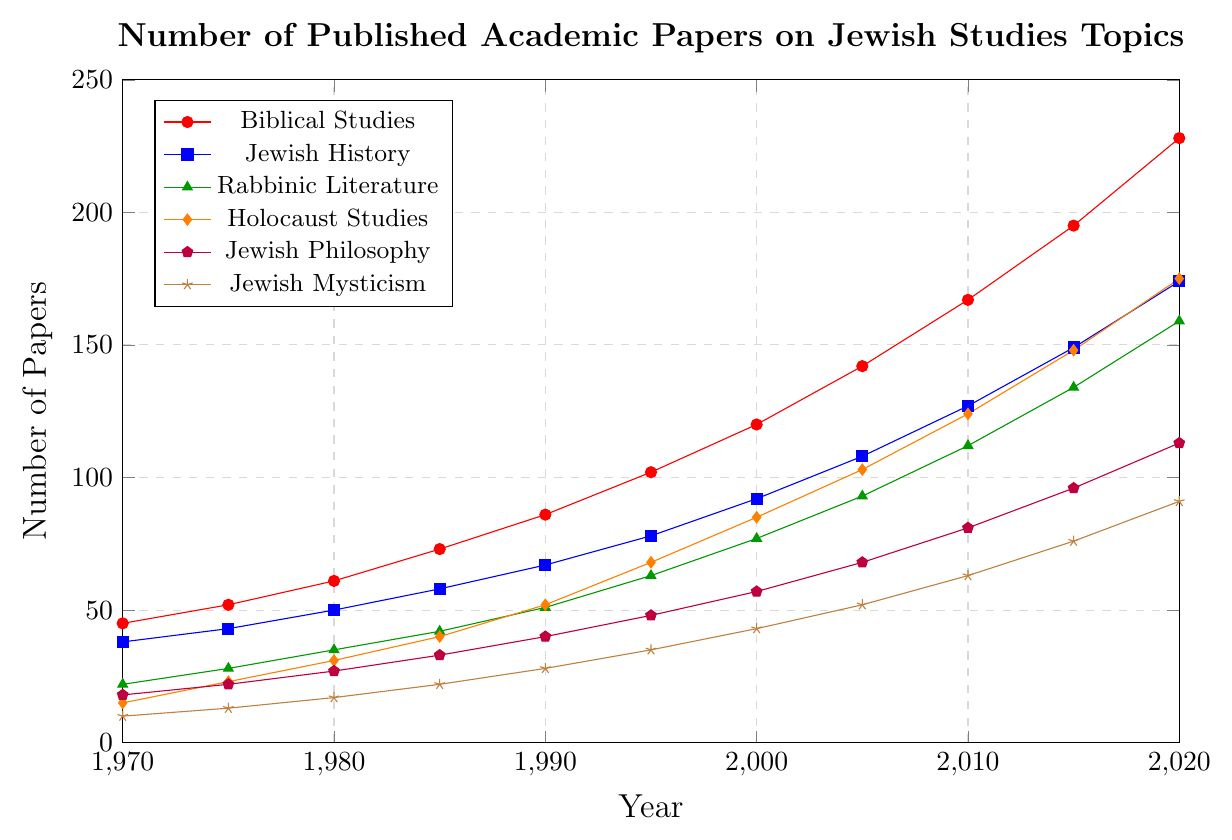What specific year does Holocaust Studies surpass 100 published papers? Examining the trend line for Holocaust Studies (orange line with diamond markers), we can see that it crosses 100 papers between 2000 and 2005. Checking the legend, we find that in 2005 the number is 103.
Answer: 2005 Between 1970 and 2020, which subject showed the largest increase in the number of published papers? To find the largest increase, we need to calculate the difference between the values at 2020 and 1970 for each subject. For Biblical Studies: 228-45=183, Jewish History: 174-38=136, Rabbinic Literature: 159-22=137, Holocaust Studies: 175-15=160, Jewish Philosophy: 113-18=95, and Jewish Mysticism: 91-10=81. The subject with the largest increase is Biblical Studies (183 papers).
Answer: Biblical Studies Which subject had the slowest growth over these 50 years, and what was the total growth in that subject? By calculating the increase for each subject, the smallest increase is in Jewish Mysticism: from 10 papers in 1970 to 91 in 2020, which is a difference of 81.
Answer: Jewish Mysticism, 81 In what year did the number of papers on Rabbinic Literature exceed those on Jewish History for the first time? Checking the trends, Rabbinic Literature surpasses Jewish History between 2010 and 2015—specifically, in 2015 where Rabbinic Literature has 134 papers and Jewish History has 149. Thus, Rabbinic Literature still does not exceed Jewish History at any point.
Answer: Never How many more papers were published in Jewish Philosophy than Jewish Mysticism in the year 2020? In 2020, Jewish Philosophy has 113 papers, and Jewish Mysticism has 91. The difference between them is 113 - 91 = 22 papers.
Answer: 22 What's the average number of papers published in Holocaust Studies per 10-year period? The total number of papers in Holocaust Studies from 1970 to 2020 is the sum of all values: 15+23+31+40+52+68+85+103+124+148+175 = 864. There are 5 decades, so the average per decade is 864 / 5 = 172.8.
Answer: 172.8 Which subject area had exactly 57 published papers in the year 2000? Reviewing the plotted data points for the year 2000, Jewish Philosophy is marked with exactly 57 published papers.
Answer: Jewish Philosophy 